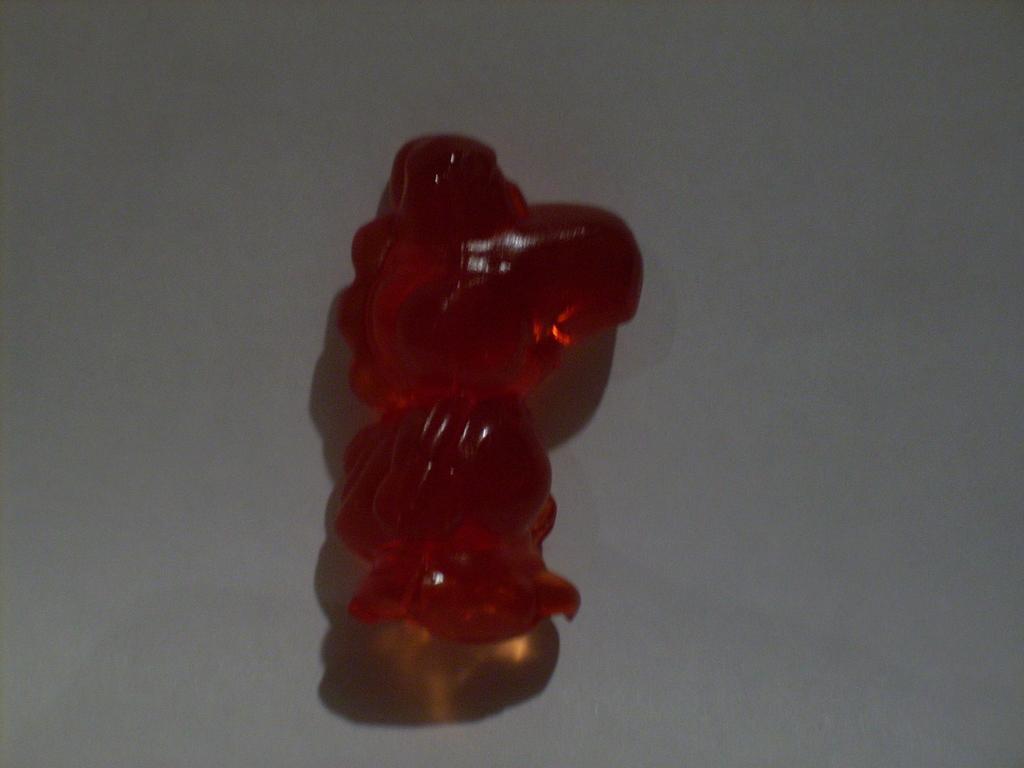How would you summarize this image in a sentence or two? There is a red color thing on a white surface. 